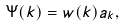<formula> <loc_0><loc_0><loc_500><loc_500>\Psi ( k ) = w ( k ) a _ { k } ,</formula> 